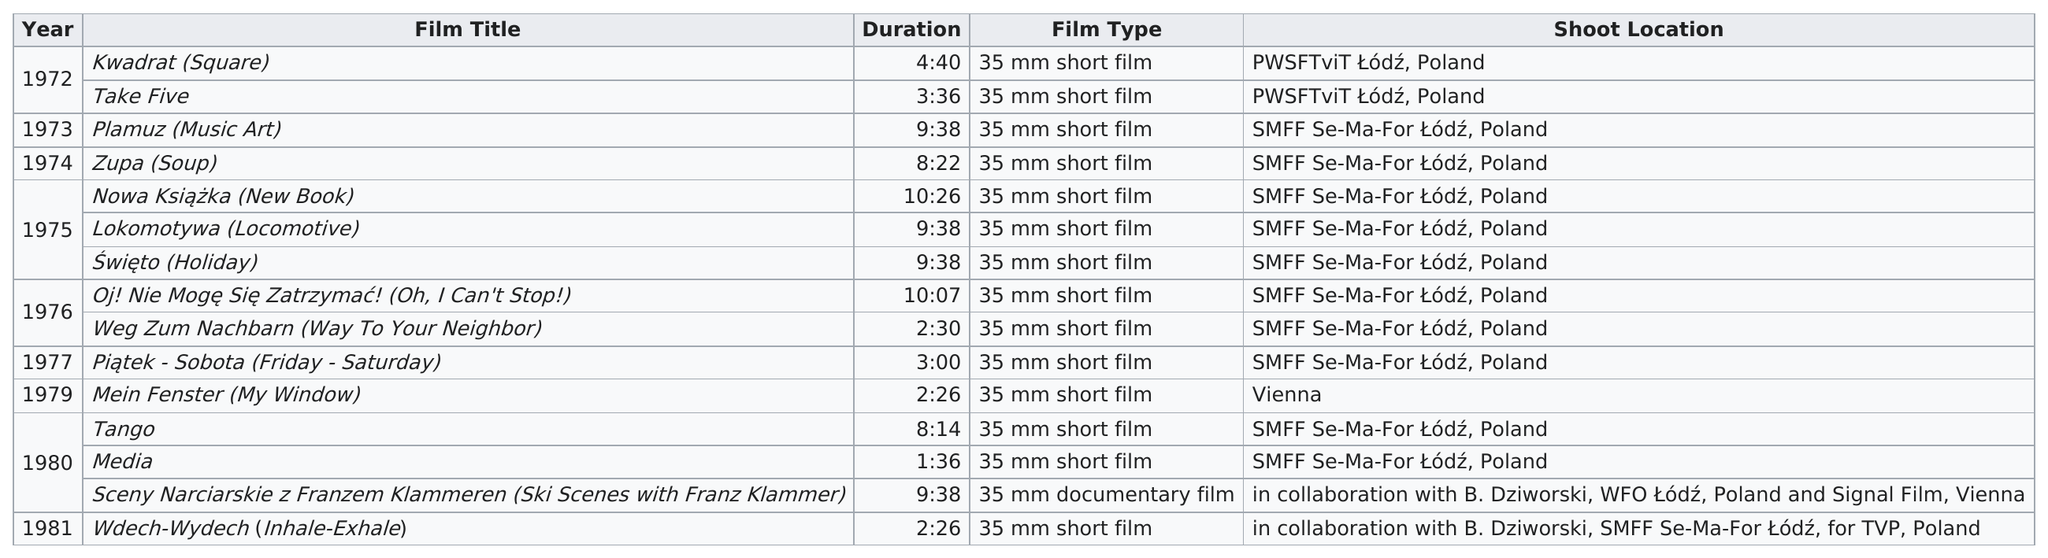Give some essential details in this illustration. Of the films, how many had a duration below 5 minutes? 7.. The films that collaborated with B. Dziworski are "Sceny Narciarskie z Franzem Klammeren (Ski Scenes with Franz Klammer) and Wdech-Wydech (Inhale-Exhale). How many films were shot in Sm FF sm-for &#321;ód&#378;, Poland? Ten. 